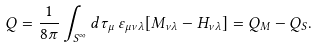Convert formula to latex. <formula><loc_0><loc_0><loc_500><loc_500>Q = \frac { 1 } { 8 \pi } \int _ { S ^ { \infty } } d \tau _ { \mu } \, \varepsilon _ { \mu \nu \lambda } [ M _ { \nu \lambda } - H _ { \nu \lambda } ] = Q _ { M } - Q _ { S } .</formula> 